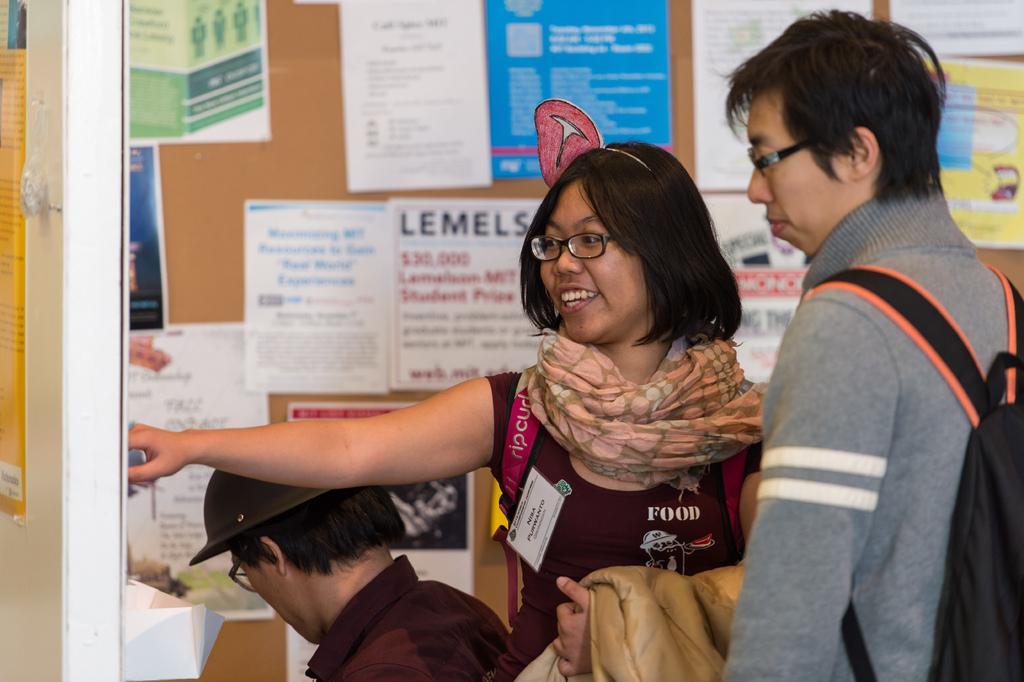Please provide a concise description of this image. In this picture there is a couple standing. One of them was a woman and other was a man. Beside the woman there is another person sitting wearing cap on his head. All of them were wearing spectacles. In the background there are some papers stuck to the notice board. 